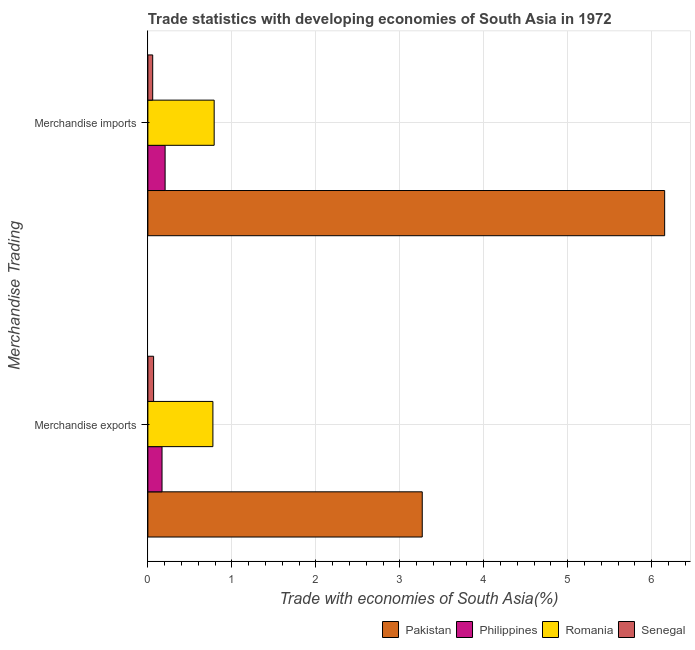How many different coloured bars are there?
Ensure brevity in your answer.  4. How many groups of bars are there?
Your response must be concise. 2. How many bars are there on the 2nd tick from the top?
Make the answer very short. 4. What is the label of the 2nd group of bars from the top?
Provide a succinct answer. Merchandise exports. What is the merchandise exports in Senegal?
Ensure brevity in your answer.  0.07. Across all countries, what is the maximum merchandise exports?
Your answer should be compact. 3.27. Across all countries, what is the minimum merchandise exports?
Your answer should be compact. 0.07. In which country was the merchandise imports minimum?
Ensure brevity in your answer.  Senegal. What is the total merchandise imports in the graph?
Make the answer very short. 7.21. What is the difference between the merchandise exports in Pakistan and that in Senegal?
Offer a very short reply. 3.2. What is the difference between the merchandise imports in Philippines and the merchandise exports in Romania?
Your response must be concise. -0.57. What is the average merchandise exports per country?
Offer a terse response. 1.07. What is the difference between the merchandise imports and merchandise exports in Pakistan?
Your response must be concise. 2.89. In how many countries, is the merchandise imports greater than 6 %?
Make the answer very short. 1. What is the ratio of the merchandise imports in Romania to that in Senegal?
Provide a succinct answer. 13.7. What does the 2nd bar from the top in Merchandise exports represents?
Your response must be concise. Romania. What does the 3rd bar from the bottom in Merchandise imports represents?
Offer a terse response. Romania. How many countries are there in the graph?
Your answer should be compact. 4. What is the difference between two consecutive major ticks on the X-axis?
Your response must be concise. 1. Does the graph contain any zero values?
Make the answer very short. No. Where does the legend appear in the graph?
Offer a terse response. Bottom right. How are the legend labels stacked?
Make the answer very short. Horizontal. What is the title of the graph?
Provide a short and direct response. Trade statistics with developing economies of South Asia in 1972. What is the label or title of the X-axis?
Offer a very short reply. Trade with economies of South Asia(%). What is the label or title of the Y-axis?
Your response must be concise. Merchandise Trading. What is the Trade with economies of South Asia(%) in Pakistan in Merchandise exports?
Your answer should be very brief. 3.27. What is the Trade with economies of South Asia(%) of Philippines in Merchandise exports?
Provide a short and direct response. 0.17. What is the Trade with economies of South Asia(%) in Romania in Merchandise exports?
Your response must be concise. 0.77. What is the Trade with economies of South Asia(%) of Senegal in Merchandise exports?
Ensure brevity in your answer.  0.07. What is the Trade with economies of South Asia(%) in Pakistan in Merchandise imports?
Keep it short and to the point. 6.15. What is the Trade with economies of South Asia(%) in Philippines in Merchandise imports?
Offer a very short reply. 0.21. What is the Trade with economies of South Asia(%) in Romania in Merchandise imports?
Give a very brief answer. 0.79. What is the Trade with economies of South Asia(%) of Senegal in Merchandise imports?
Your answer should be very brief. 0.06. Across all Merchandise Trading, what is the maximum Trade with economies of South Asia(%) in Pakistan?
Ensure brevity in your answer.  6.15. Across all Merchandise Trading, what is the maximum Trade with economies of South Asia(%) in Philippines?
Provide a succinct answer. 0.21. Across all Merchandise Trading, what is the maximum Trade with economies of South Asia(%) in Romania?
Make the answer very short. 0.79. Across all Merchandise Trading, what is the maximum Trade with economies of South Asia(%) in Senegal?
Offer a terse response. 0.07. Across all Merchandise Trading, what is the minimum Trade with economies of South Asia(%) in Pakistan?
Your answer should be compact. 3.27. Across all Merchandise Trading, what is the minimum Trade with economies of South Asia(%) of Philippines?
Provide a succinct answer. 0.17. Across all Merchandise Trading, what is the minimum Trade with economies of South Asia(%) of Romania?
Offer a very short reply. 0.77. Across all Merchandise Trading, what is the minimum Trade with economies of South Asia(%) in Senegal?
Your answer should be compact. 0.06. What is the total Trade with economies of South Asia(%) of Pakistan in the graph?
Your answer should be very brief. 9.42. What is the total Trade with economies of South Asia(%) of Philippines in the graph?
Keep it short and to the point. 0.37. What is the total Trade with economies of South Asia(%) of Romania in the graph?
Provide a short and direct response. 1.56. What is the total Trade with economies of South Asia(%) of Senegal in the graph?
Offer a terse response. 0.13. What is the difference between the Trade with economies of South Asia(%) of Pakistan in Merchandise exports and that in Merchandise imports?
Provide a succinct answer. -2.89. What is the difference between the Trade with economies of South Asia(%) in Philippines in Merchandise exports and that in Merchandise imports?
Keep it short and to the point. -0.04. What is the difference between the Trade with economies of South Asia(%) of Romania in Merchandise exports and that in Merchandise imports?
Make the answer very short. -0.02. What is the difference between the Trade with economies of South Asia(%) in Senegal in Merchandise exports and that in Merchandise imports?
Your answer should be very brief. 0.01. What is the difference between the Trade with economies of South Asia(%) in Pakistan in Merchandise exports and the Trade with economies of South Asia(%) in Philippines in Merchandise imports?
Make the answer very short. 3.06. What is the difference between the Trade with economies of South Asia(%) of Pakistan in Merchandise exports and the Trade with economies of South Asia(%) of Romania in Merchandise imports?
Your answer should be very brief. 2.48. What is the difference between the Trade with economies of South Asia(%) of Pakistan in Merchandise exports and the Trade with economies of South Asia(%) of Senegal in Merchandise imports?
Provide a short and direct response. 3.21. What is the difference between the Trade with economies of South Asia(%) in Philippines in Merchandise exports and the Trade with economies of South Asia(%) in Romania in Merchandise imports?
Ensure brevity in your answer.  -0.62. What is the difference between the Trade with economies of South Asia(%) in Philippines in Merchandise exports and the Trade with economies of South Asia(%) in Senegal in Merchandise imports?
Keep it short and to the point. 0.11. What is the difference between the Trade with economies of South Asia(%) in Romania in Merchandise exports and the Trade with economies of South Asia(%) in Senegal in Merchandise imports?
Keep it short and to the point. 0.72. What is the average Trade with economies of South Asia(%) in Pakistan per Merchandise Trading?
Provide a short and direct response. 4.71. What is the average Trade with economies of South Asia(%) in Philippines per Merchandise Trading?
Your response must be concise. 0.19. What is the average Trade with economies of South Asia(%) in Romania per Merchandise Trading?
Provide a short and direct response. 0.78. What is the average Trade with economies of South Asia(%) of Senegal per Merchandise Trading?
Your answer should be compact. 0.06. What is the difference between the Trade with economies of South Asia(%) in Pakistan and Trade with economies of South Asia(%) in Philippines in Merchandise exports?
Your answer should be compact. 3.1. What is the difference between the Trade with economies of South Asia(%) of Pakistan and Trade with economies of South Asia(%) of Romania in Merchandise exports?
Keep it short and to the point. 2.49. What is the difference between the Trade with economies of South Asia(%) of Pakistan and Trade with economies of South Asia(%) of Senegal in Merchandise exports?
Your answer should be compact. 3.2. What is the difference between the Trade with economies of South Asia(%) in Philippines and Trade with economies of South Asia(%) in Romania in Merchandise exports?
Ensure brevity in your answer.  -0.61. What is the difference between the Trade with economies of South Asia(%) of Philippines and Trade with economies of South Asia(%) of Senegal in Merchandise exports?
Your answer should be very brief. 0.1. What is the difference between the Trade with economies of South Asia(%) of Romania and Trade with economies of South Asia(%) of Senegal in Merchandise exports?
Provide a short and direct response. 0.71. What is the difference between the Trade with economies of South Asia(%) of Pakistan and Trade with economies of South Asia(%) of Philippines in Merchandise imports?
Provide a short and direct response. 5.95. What is the difference between the Trade with economies of South Asia(%) in Pakistan and Trade with economies of South Asia(%) in Romania in Merchandise imports?
Your answer should be compact. 5.36. What is the difference between the Trade with economies of South Asia(%) in Pakistan and Trade with economies of South Asia(%) in Senegal in Merchandise imports?
Provide a succinct answer. 6.1. What is the difference between the Trade with economies of South Asia(%) of Philippines and Trade with economies of South Asia(%) of Romania in Merchandise imports?
Give a very brief answer. -0.58. What is the difference between the Trade with economies of South Asia(%) in Philippines and Trade with economies of South Asia(%) in Senegal in Merchandise imports?
Make the answer very short. 0.15. What is the difference between the Trade with economies of South Asia(%) in Romania and Trade with economies of South Asia(%) in Senegal in Merchandise imports?
Your response must be concise. 0.73. What is the ratio of the Trade with economies of South Asia(%) of Pakistan in Merchandise exports to that in Merchandise imports?
Your answer should be compact. 0.53. What is the ratio of the Trade with economies of South Asia(%) of Philippines in Merchandise exports to that in Merchandise imports?
Offer a terse response. 0.82. What is the ratio of the Trade with economies of South Asia(%) of Romania in Merchandise exports to that in Merchandise imports?
Your answer should be compact. 0.98. What is the ratio of the Trade with economies of South Asia(%) in Senegal in Merchandise exports to that in Merchandise imports?
Your answer should be very brief. 1.19. What is the difference between the highest and the second highest Trade with economies of South Asia(%) in Pakistan?
Your answer should be very brief. 2.89. What is the difference between the highest and the second highest Trade with economies of South Asia(%) in Philippines?
Provide a short and direct response. 0.04. What is the difference between the highest and the second highest Trade with economies of South Asia(%) in Romania?
Provide a succinct answer. 0.02. What is the difference between the highest and the second highest Trade with economies of South Asia(%) in Senegal?
Make the answer very short. 0.01. What is the difference between the highest and the lowest Trade with economies of South Asia(%) of Pakistan?
Your answer should be compact. 2.89. What is the difference between the highest and the lowest Trade with economies of South Asia(%) of Philippines?
Provide a succinct answer. 0.04. What is the difference between the highest and the lowest Trade with economies of South Asia(%) in Romania?
Give a very brief answer. 0.02. What is the difference between the highest and the lowest Trade with economies of South Asia(%) of Senegal?
Provide a short and direct response. 0.01. 